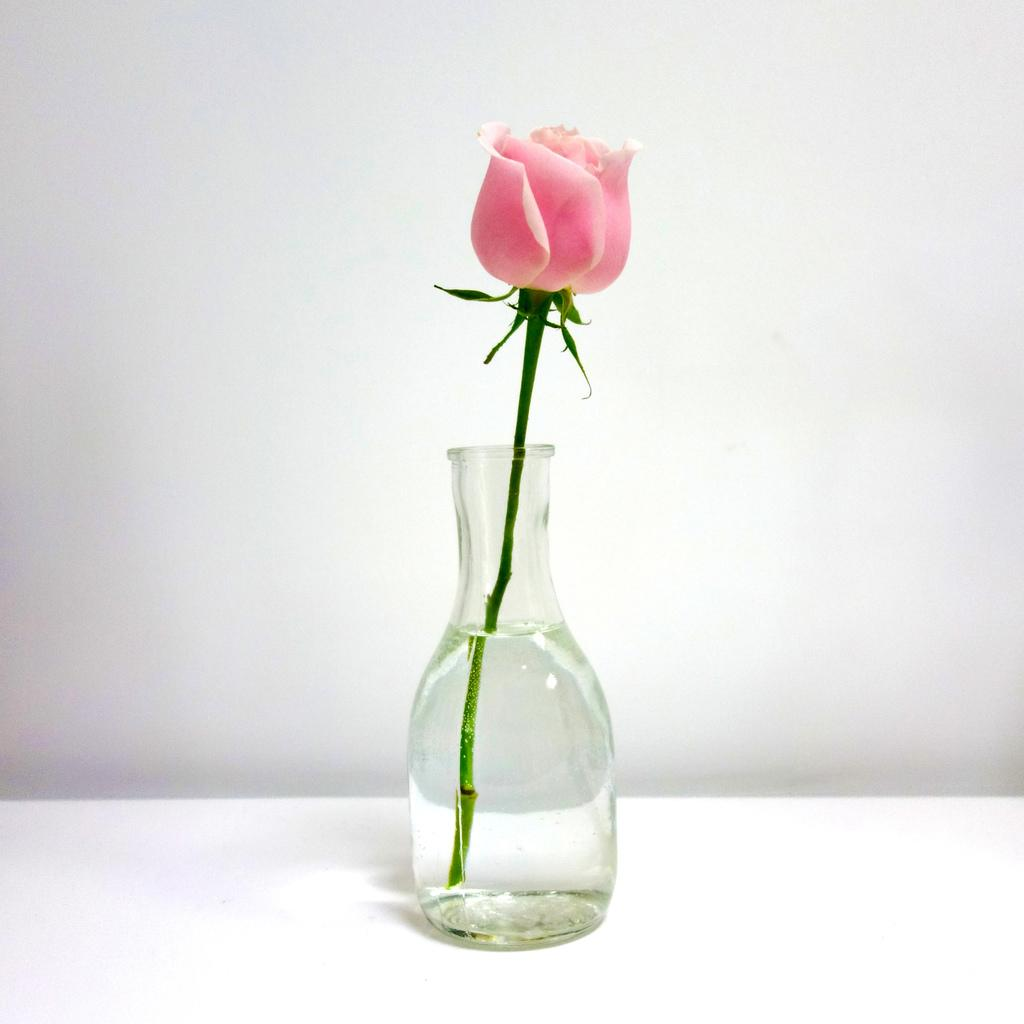What type of flower is in the image? There is a pink color rose in the image. How is the rose displayed in the image? The rose is kept in a small glass jar. Where is the jar with the rose placed? The jar is placed on a table. What can be seen in the background of the image? There is a wall in the background of the image. Are there any fairies flying around the rose in the image? There are no fairies present in the image; it only features a pink rose in a small glass jar on a table with a wall in the background. 